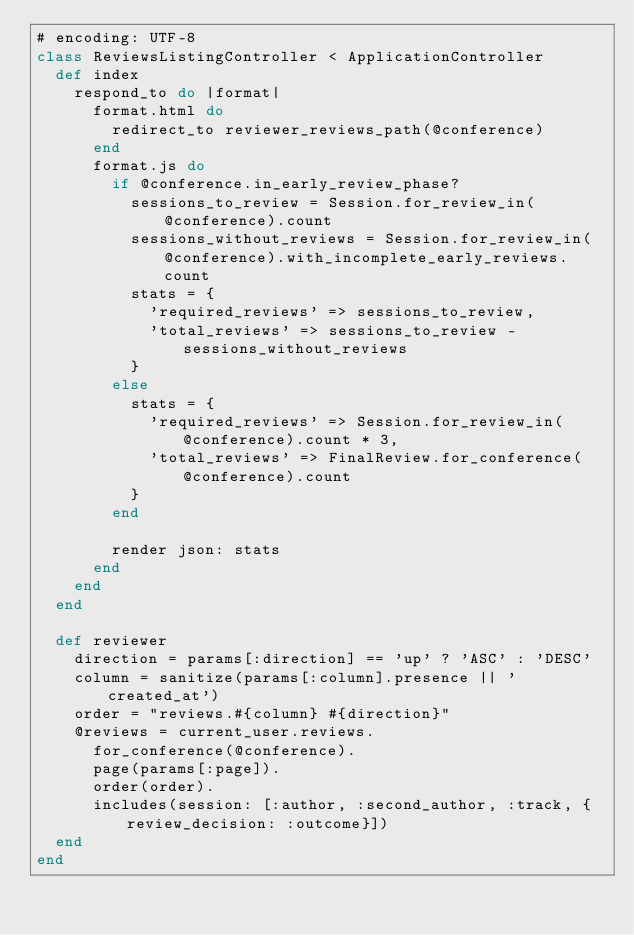Convert code to text. <code><loc_0><loc_0><loc_500><loc_500><_Ruby_># encoding: UTF-8
class ReviewsListingController < ApplicationController
  def index
    respond_to do |format|
      format.html do
        redirect_to reviewer_reviews_path(@conference)
      end
      format.js do
        if @conference.in_early_review_phase?
          sessions_to_review = Session.for_review_in(@conference).count
          sessions_without_reviews = Session.for_review_in(@conference).with_incomplete_early_reviews.count
          stats = {
            'required_reviews' => sessions_to_review,
            'total_reviews' => sessions_to_review - sessions_without_reviews
          }
        else
          stats = {
            'required_reviews' => Session.for_review_in(@conference).count * 3,
            'total_reviews' => FinalReview.for_conference(@conference).count
          }
        end

        render json: stats
      end
    end
  end

  def reviewer
    direction = params[:direction] == 'up' ? 'ASC' : 'DESC'
    column = sanitize(params[:column].presence || 'created_at')
    order = "reviews.#{column} #{direction}"
    @reviews = current_user.reviews.
      for_conference(@conference).
      page(params[:page]).
      order(order).
      includes(session: [:author, :second_author, :track, {review_decision: :outcome}])
  end
end
</code> 